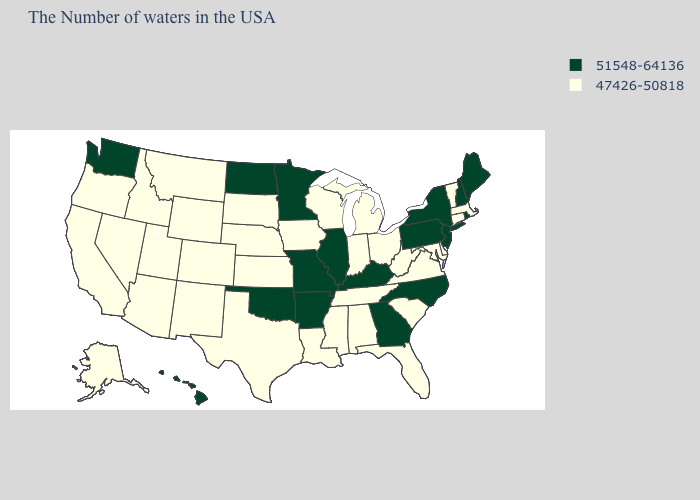Does Iowa have a lower value than North Dakota?
Be succinct. Yes. Among the states that border South Carolina , which have the lowest value?
Short answer required. North Carolina, Georgia. What is the value of Alabama?
Concise answer only. 47426-50818. What is the value of North Carolina?
Give a very brief answer. 51548-64136. Does Maine have the highest value in the USA?
Short answer required. Yes. Does West Virginia have the same value as Virginia?
Keep it brief. Yes. Does Illinois have the same value as Tennessee?
Concise answer only. No. What is the value of South Carolina?
Give a very brief answer. 47426-50818. What is the value of California?
Short answer required. 47426-50818. Name the states that have a value in the range 47426-50818?
Keep it brief. Massachusetts, Vermont, Connecticut, Delaware, Maryland, Virginia, South Carolina, West Virginia, Ohio, Florida, Michigan, Indiana, Alabama, Tennessee, Wisconsin, Mississippi, Louisiana, Iowa, Kansas, Nebraska, Texas, South Dakota, Wyoming, Colorado, New Mexico, Utah, Montana, Arizona, Idaho, Nevada, California, Oregon, Alaska. What is the value of Connecticut?
Answer briefly. 47426-50818. Does Washington have a lower value than South Carolina?
Give a very brief answer. No. Does the first symbol in the legend represent the smallest category?
Be succinct. No. What is the value of Hawaii?
Keep it brief. 51548-64136. Does Idaho have the same value as Kansas?
Keep it brief. Yes. 